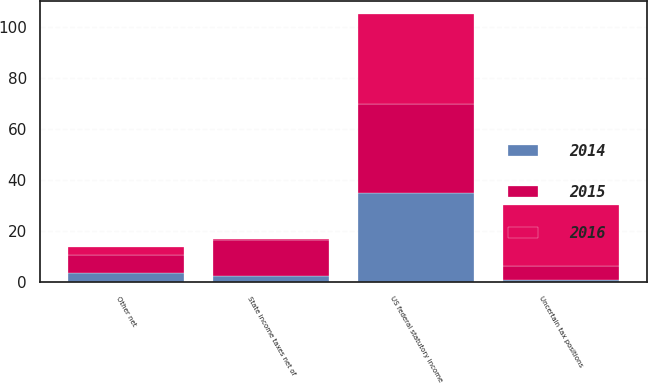<chart> <loc_0><loc_0><loc_500><loc_500><stacked_bar_chart><ecel><fcel>US federal statutory income<fcel>State income taxes net of<fcel>Uncertain tax positions<fcel>Other net<nl><fcel>2016<fcel>35<fcel>0.4<fcel>23.7<fcel>3.2<nl><fcel>2015<fcel>35<fcel>14.1<fcel>5.8<fcel>7<nl><fcel>2014<fcel>35<fcel>2.4<fcel>0.7<fcel>3.7<nl></chart> 